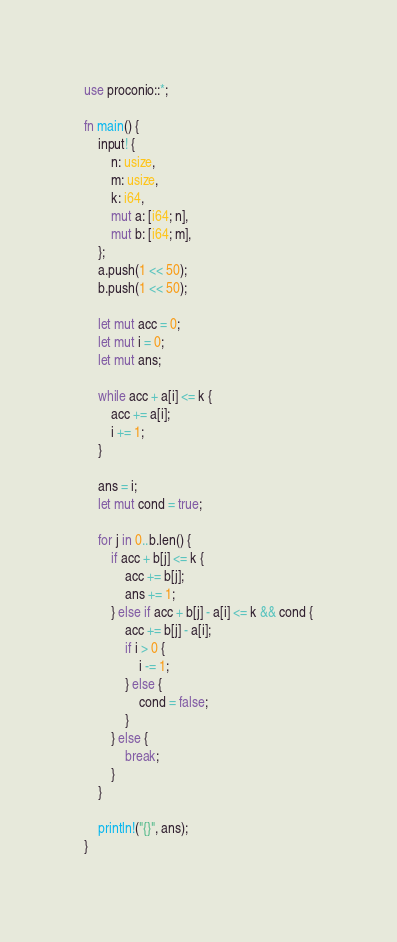<code> <loc_0><loc_0><loc_500><loc_500><_Rust_>use proconio::*;

fn main() {
    input! {
        n: usize,
        m: usize,
        k: i64,
        mut a: [i64; n],
        mut b: [i64; m],
    };
    a.push(1 << 50);
    b.push(1 << 50);

    let mut acc = 0;
    let mut i = 0;
    let mut ans;

    while acc + a[i] <= k {
        acc += a[i];
        i += 1;
    }

    ans = i;
    let mut cond = true;

    for j in 0..b.len() {
        if acc + b[j] <= k {
            acc += b[j];
            ans += 1;
        } else if acc + b[j] - a[i] <= k && cond {
            acc += b[j] - a[i];
            if i > 0 {
                i -= 1;
            } else {
                cond = false;
            }
        } else {
            break;
        }
    }

    println!("{}", ans);
}
</code> 